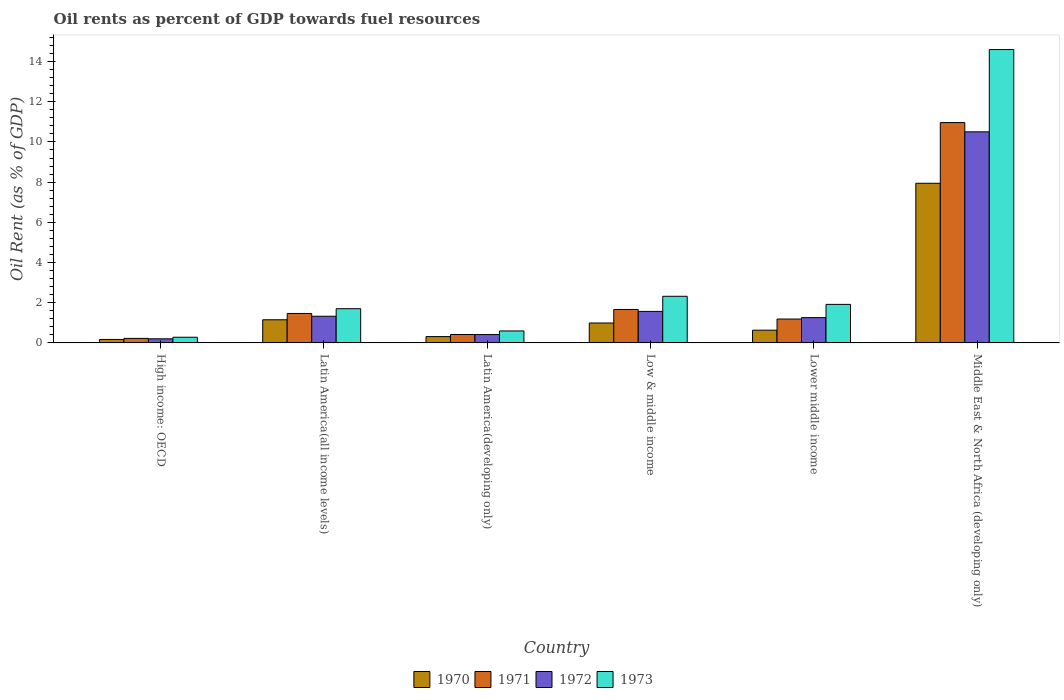How many different coloured bars are there?
Your answer should be very brief. 4. Are the number of bars per tick equal to the number of legend labels?
Give a very brief answer. Yes. In how many cases, is the number of bars for a given country not equal to the number of legend labels?
Provide a short and direct response. 0. What is the oil rent in 1973 in Latin America(developing only)?
Make the answer very short. 0.6. Across all countries, what is the maximum oil rent in 1971?
Keep it short and to the point. 10.96. Across all countries, what is the minimum oil rent in 1970?
Your answer should be compact. 0.17. In which country was the oil rent in 1972 maximum?
Ensure brevity in your answer.  Middle East & North Africa (developing only). In which country was the oil rent in 1972 minimum?
Provide a succinct answer. High income: OECD. What is the total oil rent in 1970 in the graph?
Your answer should be compact. 11.21. What is the difference between the oil rent in 1970 in Latin America(all income levels) and that in Lower middle income?
Offer a very short reply. 0.52. What is the difference between the oil rent in 1972 in Middle East & North Africa (developing only) and the oil rent in 1973 in Lower middle income?
Give a very brief answer. 8.58. What is the average oil rent in 1973 per country?
Provide a short and direct response. 3.57. What is the difference between the oil rent of/in 1972 and oil rent of/in 1971 in High income: OECD?
Give a very brief answer. -0.02. What is the ratio of the oil rent in 1973 in Latin America(all income levels) to that in Middle East & North Africa (developing only)?
Your answer should be compact. 0.12. Is the oil rent in 1970 in High income: OECD less than that in Low & middle income?
Offer a terse response. Yes. What is the difference between the highest and the second highest oil rent in 1971?
Provide a succinct answer. -9.3. What is the difference between the highest and the lowest oil rent in 1970?
Your answer should be compact. 7.77. In how many countries, is the oil rent in 1972 greater than the average oil rent in 1972 taken over all countries?
Provide a succinct answer. 1. What does the 2nd bar from the right in Low & middle income represents?
Give a very brief answer. 1972. How many bars are there?
Ensure brevity in your answer.  24. Are all the bars in the graph horizontal?
Your response must be concise. No. What is the difference between two consecutive major ticks on the Y-axis?
Your answer should be compact. 2. Does the graph contain any zero values?
Keep it short and to the point. No. How many legend labels are there?
Make the answer very short. 4. How are the legend labels stacked?
Your answer should be compact. Horizontal. What is the title of the graph?
Your response must be concise. Oil rents as percent of GDP towards fuel resources. What is the label or title of the Y-axis?
Ensure brevity in your answer.  Oil Rent (as % of GDP). What is the Oil Rent (as % of GDP) of 1970 in High income: OECD?
Keep it short and to the point. 0.17. What is the Oil Rent (as % of GDP) of 1971 in High income: OECD?
Your answer should be very brief. 0.23. What is the Oil Rent (as % of GDP) in 1972 in High income: OECD?
Your answer should be compact. 0.21. What is the Oil Rent (as % of GDP) of 1973 in High income: OECD?
Your answer should be compact. 0.28. What is the Oil Rent (as % of GDP) of 1970 in Latin America(all income levels)?
Make the answer very short. 1.15. What is the Oil Rent (as % of GDP) in 1971 in Latin America(all income levels)?
Give a very brief answer. 1.47. What is the Oil Rent (as % of GDP) in 1972 in Latin America(all income levels)?
Offer a very short reply. 1.33. What is the Oil Rent (as % of GDP) of 1973 in Latin America(all income levels)?
Give a very brief answer. 1.7. What is the Oil Rent (as % of GDP) in 1970 in Latin America(developing only)?
Offer a very short reply. 0.32. What is the Oil Rent (as % of GDP) of 1971 in Latin America(developing only)?
Your response must be concise. 0.42. What is the Oil Rent (as % of GDP) of 1972 in Latin America(developing only)?
Ensure brevity in your answer.  0.42. What is the Oil Rent (as % of GDP) in 1973 in Latin America(developing only)?
Your response must be concise. 0.6. What is the Oil Rent (as % of GDP) of 1970 in Low & middle income?
Provide a short and direct response. 0.99. What is the Oil Rent (as % of GDP) in 1971 in Low & middle income?
Your answer should be very brief. 1.67. What is the Oil Rent (as % of GDP) of 1972 in Low & middle income?
Ensure brevity in your answer.  1.57. What is the Oil Rent (as % of GDP) in 1973 in Low & middle income?
Keep it short and to the point. 2.32. What is the Oil Rent (as % of GDP) of 1970 in Lower middle income?
Ensure brevity in your answer.  0.63. What is the Oil Rent (as % of GDP) of 1971 in Lower middle income?
Give a very brief answer. 1.19. What is the Oil Rent (as % of GDP) in 1972 in Lower middle income?
Your answer should be compact. 1.26. What is the Oil Rent (as % of GDP) in 1973 in Lower middle income?
Make the answer very short. 1.92. What is the Oil Rent (as % of GDP) of 1970 in Middle East & North Africa (developing only)?
Ensure brevity in your answer.  7.94. What is the Oil Rent (as % of GDP) in 1971 in Middle East & North Africa (developing only)?
Ensure brevity in your answer.  10.96. What is the Oil Rent (as % of GDP) of 1972 in Middle East & North Africa (developing only)?
Offer a very short reply. 10.5. What is the Oil Rent (as % of GDP) of 1973 in Middle East & North Africa (developing only)?
Your answer should be compact. 14.6. Across all countries, what is the maximum Oil Rent (as % of GDP) of 1970?
Your answer should be compact. 7.94. Across all countries, what is the maximum Oil Rent (as % of GDP) in 1971?
Make the answer very short. 10.96. Across all countries, what is the maximum Oil Rent (as % of GDP) in 1972?
Provide a succinct answer. 10.5. Across all countries, what is the maximum Oil Rent (as % of GDP) in 1973?
Provide a succinct answer. 14.6. Across all countries, what is the minimum Oil Rent (as % of GDP) of 1970?
Give a very brief answer. 0.17. Across all countries, what is the minimum Oil Rent (as % of GDP) of 1971?
Keep it short and to the point. 0.23. Across all countries, what is the minimum Oil Rent (as % of GDP) in 1972?
Provide a short and direct response. 0.21. Across all countries, what is the minimum Oil Rent (as % of GDP) of 1973?
Keep it short and to the point. 0.28. What is the total Oil Rent (as % of GDP) in 1970 in the graph?
Make the answer very short. 11.21. What is the total Oil Rent (as % of GDP) in 1971 in the graph?
Your answer should be compact. 15.93. What is the total Oil Rent (as % of GDP) in 1972 in the graph?
Offer a very short reply. 15.28. What is the total Oil Rent (as % of GDP) in 1973 in the graph?
Your response must be concise. 21.42. What is the difference between the Oil Rent (as % of GDP) in 1970 in High income: OECD and that in Latin America(all income levels)?
Ensure brevity in your answer.  -0.98. What is the difference between the Oil Rent (as % of GDP) of 1971 in High income: OECD and that in Latin America(all income levels)?
Ensure brevity in your answer.  -1.24. What is the difference between the Oil Rent (as % of GDP) of 1972 in High income: OECD and that in Latin America(all income levels)?
Offer a terse response. -1.12. What is the difference between the Oil Rent (as % of GDP) of 1973 in High income: OECD and that in Latin America(all income levels)?
Offer a very short reply. -1.42. What is the difference between the Oil Rent (as % of GDP) in 1970 in High income: OECD and that in Latin America(developing only)?
Ensure brevity in your answer.  -0.14. What is the difference between the Oil Rent (as % of GDP) of 1971 in High income: OECD and that in Latin America(developing only)?
Give a very brief answer. -0.19. What is the difference between the Oil Rent (as % of GDP) of 1972 in High income: OECD and that in Latin America(developing only)?
Provide a short and direct response. -0.21. What is the difference between the Oil Rent (as % of GDP) of 1973 in High income: OECD and that in Latin America(developing only)?
Your answer should be compact. -0.31. What is the difference between the Oil Rent (as % of GDP) of 1970 in High income: OECD and that in Low & middle income?
Your answer should be compact. -0.82. What is the difference between the Oil Rent (as % of GDP) in 1971 in High income: OECD and that in Low & middle income?
Keep it short and to the point. -1.44. What is the difference between the Oil Rent (as % of GDP) of 1972 in High income: OECD and that in Low & middle income?
Provide a succinct answer. -1.36. What is the difference between the Oil Rent (as % of GDP) of 1973 in High income: OECD and that in Low & middle income?
Make the answer very short. -2.04. What is the difference between the Oil Rent (as % of GDP) in 1970 in High income: OECD and that in Lower middle income?
Offer a very short reply. -0.46. What is the difference between the Oil Rent (as % of GDP) in 1971 in High income: OECD and that in Lower middle income?
Keep it short and to the point. -0.96. What is the difference between the Oil Rent (as % of GDP) in 1972 in High income: OECD and that in Lower middle income?
Provide a short and direct response. -1.05. What is the difference between the Oil Rent (as % of GDP) in 1973 in High income: OECD and that in Lower middle income?
Your response must be concise. -1.64. What is the difference between the Oil Rent (as % of GDP) in 1970 in High income: OECD and that in Middle East & North Africa (developing only)?
Keep it short and to the point. -7.77. What is the difference between the Oil Rent (as % of GDP) in 1971 in High income: OECD and that in Middle East & North Africa (developing only)?
Offer a very short reply. -10.74. What is the difference between the Oil Rent (as % of GDP) of 1972 in High income: OECD and that in Middle East & North Africa (developing only)?
Keep it short and to the point. -10.3. What is the difference between the Oil Rent (as % of GDP) in 1973 in High income: OECD and that in Middle East & North Africa (developing only)?
Provide a short and direct response. -14.31. What is the difference between the Oil Rent (as % of GDP) of 1970 in Latin America(all income levels) and that in Latin America(developing only)?
Provide a succinct answer. 0.84. What is the difference between the Oil Rent (as % of GDP) of 1971 in Latin America(all income levels) and that in Latin America(developing only)?
Your answer should be compact. 1.05. What is the difference between the Oil Rent (as % of GDP) in 1972 in Latin America(all income levels) and that in Latin America(developing only)?
Offer a terse response. 0.91. What is the difference between the Oil Rent (as % of GDP) of 1973 in Latin America(all income levels) and that in Latin America(developing only)?
Ensure brevity in your answer.  1.11. What is the difference between the Oil Rent (as % of GDP) in 1970 in Latin America(all income levels) and that in Low & middle income?
Your response must be concise. 0.16. What is the difference between the Oil Rent (as % of GDP) of 1971 in Latin America(all income levels) and that in Low & middle income?
Ensure brevity in your answer.  -0.2. What is the difference between the Oil Rent (as % of GDP) of 1972 in Latin America(all income levels) and that in Low & middle income?
Make the answer very short. -0.24. What is the difference between the Oil Rent (as % of GDP) of 1973 in Latin America(all income levels) and that in Low & middle income?
Offer a very short reply. -0.62. What is the difference between the Oil Rent (as % of GDP) in 1970 in Latin America(all income levels) and that in Lower middle income?
Make the answer very short. 0.52. What is the difference between the Oil Rent (as % of GDP) of 1971 in Latin America(all income levels) and that in Lower middle income?
Your answer should be compact. 0.28. What is the difference between the Oil Rent (as % of GDP) of 1972 in Latin America(all income levels) and that in Lower middle income?
Give a very brief answer. 0.07. What is the difference between the Oil Rent (as % of GDP) of 1973 in Latin America(all income levels) and that in Lower middle income?
Provide a succinct answer. -0.21. What is the difference between the Oil Rent (as % of GDP) in 1970 in Latin America(all income levels) and that in Middle East & North Africa (developing only)?
Keep it short and to the point. -6.79. What is the difference between the Oil Rent (as % of GDP) of 1971 in Latin America(all income levels) and that in Middle East & North Africa (developing only)?
Offer a very short reply. -9.5. What is the difference between the Oil Rent (as % of GDP) in 1972 in Latin America(all income levels) and that in Middle East & North Africa (developing only)?
Give a very brief answer. -9.17. What is the difference between the Oil Rent (as % of GDP) of 1973 in Latin America(all income levels) and that in Middle East & North Africa (developing only)?
Make the answer very short. -12.89. What is the difference between the Oil Rent (as % of GDP) in 1970 in Latin America(developing only) and that in Low & middle income?
Your answer should be very brief. -0.68. What is the difference between the Oil Rent (as % of GDP) in 1971 in Latin America(developing only) and that in Low & middle income?
Offer a very short reply. -1.25. What is the difference between the Oil Rent (as % of GDP) in 1972 in Latin America(developing only) and that in Low & middle income?
Your answer should be compact. -1.15. What is the difference between the Oil Rent (as % of GDP) of 1973 in Latin America(developing only) and that in Low & middle income?
Offer a terse response. -1.72. What is the difference between the Oil Rent (as % of GDP) in 1970 in Latin America(developing only) and that in Lower middle income?
Offer a very short reply. -0.32. What is the difference between the Oil Rent (as % of GDP) of 1971 in Latin America(developing only) and that in Lower middle income?
Offer a terse response. -0.77. What is the difference between the Oil Rent (as % of GDP) in 1972 in Latin America(developing only) and that in Lower middle income?
Ensure brevity in your answer.  -0.84. What is the difference between the Oil Rent (as % of GDP) of 1973 in Latin America(developing only) and that in Lower middle income?
Your response must be concise. -1.32. What is the difference between the Oil Rent (as % of GDP) of 1970 in Latin America(developing only) and that in Middle East & North Africa (developing only)?
Offer a very short reply. -7.63. What is the difference between the Oil Rent (as % of GDP) in 1971 in Latin America(developing only) and that in Middle East & North Africa (developing only)?
Your response must be concise. -10.54. What is the difference between the Oil Rent (as % of GDP) of 1972 in Latin America(developing only) and that in Middle East & North Africa (developing only)?
Offer a very short reply. -10.09. What is the difference between the Oil Rent (as % of GDP) of 1973 in Latin America(developing only) and that in Middle East & North Africa (developing only)?
Make the answer very short. -14. What is the difference between the Oil Rent (as % of GDP) in 1970 in Low & middle income and that in Lower middle income?
Offer a terse response. 0.36. What is the difference between the Oil Rent (as % of GDP) of 1971 in Low & middle income and that in Lower middle income?
Keep it short and to the point. 0.48. What is the difference between the Oil Rent (as % of GDP) in 1972 in Low & middle income and that in Lower middle income?
Make the answer very short. 0.31. What is the difference between the Oil Rent (as % of GDP) of 1973 in Low & middle income and that in Lower middle income?
Offer a terse response. 0.4. What is the difference between the Oil Rent (as % of GDP) in 1970 in Low & middle income and that in Middle East & North Africa (developing only)?
Offer a terse response. -6.95. What is the difference between the Oil Rent (as % of GDP) of 1971 in Low & middle income and that in Middle East & North Africa (developing only)?
Give a very brief answer. -9.3. What is the difference between the Oil Rent (as % of GDP) in 1972 in Low & middle income and that in Middle East & North Africa (developing only)?
Offer a very short reply. -8.93. What is the difference between the Oil Rent (as % of GDP) in 1973 in Low & middle income and that in Middle East & North Africa (developing only)?
Your answer should be compact. -12.28. What is the difference between the Oil Rent (as % of GDP) in 1970 in Lower middle income and that in Middle East & North Africa (developing only)?
Provide a succinct answer. -7.31. What is the difference between the Oil Rent (as % of GDP) in 1971 in Lower middle income and that in Middle East & North Africa (developing only)?
Provide a short and direct response. -9.77. What is the difference between the Oil Rent (as % of GDP) of 1972 in Lower middle income and that in Middle East & North Africa (developing only)?
Offer a terse response. -9.24. What is the difference between the Oil Rent (as % of GDP) in 1973 in Lower middle income and that in Middle East & North Africa (developing only)?
Provide a succinct answer. -12.68. What is the difference between the Oil Rent (as % of GDP) in 1970 in High income: OECD and the Oil Rent (as % of GDP) in 1971 in Latin America(all income levels)?
Your response must be concise. -1.29. What is the difference between the Oil Rent (as % of GDP) in 1970 in High income: OECD and the Oil Rent (as % of GDP) in 1972 in Latin America(all income levels)?
Your response must be concise. -1.15. What is the difference between the Oil Rent (as % of GDP) of 1970 in High income: OECD and the Oil Rent (as % of GDP) of 1973 in Latin America(all income levels)?
Your answer should be very brief. -1.53. What is the difference between the Oil Rent (as % of GDP) of 1971 in High income: OECD and the Oil Rent (as % of GDP) of 1972 in Latin America(all income levels)?
Keep it short and to the point. -1.1. What is the difference between the Oil Rent (as % of GDP) in 1971 in High income: OECD and the Oil Rent (as % of GDP) in 1973 in Latin America(all income levels)?
Your answer should be compact. -1.48. What is the difference between the Oil Rent (as % of GDP) in 1972 in High income: OECD and the Oil Rent (as % of GDP) in 1973 in Latin America(all income levels)?
Provide a succinct answer. -1.5. What is the difference between the Oil Rent (as % of GDP) in 1970 in High income: OECD and the Oil Rent (as % of GDP) in 1971 in Latin America(developing only)?
Your answer should be compact. -0.25. What is the difference between the Oil Rent (as % of GDP) of 1970 in High income: OECD and the Oil Rent (as % of GDP) of 1972 in Latin America(developing only)?
Provide a short and direct response. -0.24. What is the difference between the Oil Rent (as % of GDP) of 1970 in High income: OECD and the Oil Rent (as % of GDP) of 1973 in Latin America(developing only)?
Ensure brevity in your answer.  -0.42. What is the difference between the Oil Rent (as % of GDP) in 1971 in High income: OECD and the Oil Rent (as % of GDP) in 1972 in Latin America(developing only)?
Your response must be concise. -0.19. What is the difference between the Oil Rent (as % of GDP) of 1971 in High income: OECD and the Oil Rent (as % of GDP) of 1973 in Latin America(developing only)?
Offer a very short reply. -0.37. What is the difference between the Oil Rent (as % of GDP) of 1972 in High income: OECD and the Oil Rent (as % of GDP) of 1973 in Latin America(developing only)?
Your answer should be compact. -0.39. What is the difference between the Oil Rent (as % of GDP) in 1970 in High income: OECD and the Oil Rent (as % of GDP) in 1971 in Low & middle income?
Your answer should be compact. -1.49. What is the difference between the Oil Rent (as % of GDP) in 1970 in High income: OECD and the Oil Rent (as % of GDP) in 1972 in Low & middle income?
Make the answer very short. -1.4. What is the difference between the Oil Rent (as % of GDP) in 1970 in High income: OECD and the Oil Rent (as % of GDP) in 1973 in Low & middle income?
Provide a succinct answer. -2.15. What is the difference between the Oil Rent (as % of GDP) in 1971 in High income: OECD and the Oil Rent (as % of GDP) in 1972 in Low & middle income?
Your answer should be compact. -1.34. What is the difference between the Oil Rent (as % of GDP) of 1971 in High income: OECD and the Oil Rent (as % of GDP) of 1973 in Low & middle income?
Your answer should be compact. -2.1. What is the difference between the Oil Rent (as % of GDP) of 1972 in High income: OECD and the Oil Rent (as % of GDP) of 1973 in Low & middle income?
Make the answer very short. -2.12. What is the difference between the Oil Rent (as % of GDP) of 1970 in High income: OECD and the Oil Rent (as % of GDP) of 1971 in Lower middle income?
Give a very brief answer. -1.02. What is the difference between the Oil Rent (as % of GDP) of 1970 in High income: OECD and the Oil Rent (as % of GDP) of 1972 in Lower middle income?
Give a very brief answer. -1.09. What is the difference between the Oil Rent (as % of GDP) of 1970 in High income: OECD and the Oil Rent (as % of GDP) of 1973 in Lower middle income?
Give a very brief answer. -1.74. What is the difference between the Oil Rent (as % of GDP) of 1971 in High income: OECD and the Oil Rent (as % of GDP) of 1972 in Lower middle income?
Your answer should be compact. -1.03. What is the difference between the Oil Rent (as % of GDP) of 1971 in High income: OECD and the Oil Rent (as % of GDP) of 1973 in Lower middle income?
Your response must be concise. -1.69. What is the difference between the Oil Rent (as % of GDP) of 1972 in High income: OECD and the Oil Rent (as % of GDP) of 1973 in Lower middle income?
Your response must be concise. -1.71. What is the difference between the Oil Rent (as % of GDP) of 1970 in High income: OECD and the Oil Rent (as % of GDP) of 1971 in Middle East & North Africa (developing only)?
Ensure brevity in your answer.  -10.79. What is the difference between the Oil Rent (as % of GDP) of 1970 in High income: OECD and the Oil Rent (as % of GDP) of 1972 in Middle East & North Africa (developing only)?
Offer a very short reply. -10.33. What is the difference between the Oil Rent (as % of GDP) in 1970 in High income: OECD and the Oil Rent (as % of GDP) in 1973 in Middle East & North Africa (developing only)?
Your answer should be compact. -14.42. What is the difference between the Oil Rent (as % of GDP) of 1971 in High income: OECD and the Oil Rent (as % of GDP) of 1972 in Middle East & North Africa (developing only)?
Offer a very short reply. -10.28. What is the difference between the Oil Rent (as % of GDP) of 1971 in High income: OECD and the Oil Rent (as % of GDP) of 1973 in Middle East & North Africa (developing only)?
Provide a succinct answer. -14.37. What is the difference between the Oil Rent (as % of GDP) of 1972 in High income: OECD and the Oil Rent (as % of GDP) of 1973 in Middle East & North Africa (developing only)?
Your answer should be compact. -14.39. What is the difference between the Oil Rent (as % of GDP) in 1970 in Latin America(all income levels) and the Oil Rent (as % of GDP) in 1971 in Latin America(developing only)?
Your response must be concise. 0.73. What is the difference between the Oil Rent (as % of GDP) of 1970 in Latin America(all income levels) and the Oil Rent (as % of GDP) of 1972 in Latin America(developing only)?
Offer a very short reply. 0.74. What is the difference between the Oil Rent (as % of GDP) in 1970 in Latin America(all income levels) and the Oil Rent (as % of GDP) in 1973 in Latin America(developing only)?
Make the answer very short. 0.56. What is the difference between the Oil Rent (as % of GDP) in 1971 in Latin America(all income levels) and the Oil Rent (as % of GDP) in 1972 in Latin America(developing only)?
Keep it short and to the point. 1.05. What is the difference between the Oil Rent (as % of GDP) of 1971 in Latin America(all income levels) and the Oil Rent (as % of GDP) of 1973 in Latin America(developing only)?
Your response must be concise. 0.87. What is the difference between the Oil Rent (as % of GDP) in 1972 in Latin America(all income levels) and the Oil Rent (as % of GDP) in 1973 in Latin America(developing only)?
Provide a short and direct response. 0.73. What is the difference between the Oil Rent (as % of GDP) of 1970 in Latin America(all income levels) and the Oil Rent (as % of GDP) of 1971 in Low & middle income?
Provide a succinct answer. -0.51. What is the difference between the Oil Rent (as % of GDP) in 1970 in Latin America(all income levels) and the Oil Rent (as % of GDP) in 1972 in Low & middle income?
Your response must be concise. -0.42. What is the difference between the Oil Rent (as % of GDP) of 1970 in Latin America(all income levels) and the Oil Rent (as % of GDP) of 1973 in Low & middle income?
Give a very brief answer. -1.17. What is the difference between the Oil Rent (as % of GDP) in 1971 in Latin America(all income levels) and the Oil Rent (as % of GDP) in 1972 in Low & middle income?
Ensure brevity in your answer.  -0.1. What is the difference between the Oil Rent (as % of GDP) in 1971 in Latin America(all income levels) and the Oil Rent (as % of GDP) in 1973 in Low & middle income?
Your response must be concise. -0.85. What is the difference between the Oil Rent (as % of GDP) in 1972 in Latin America(all income levels) and the Oil Rent (as % of GDP) in 1973 in Low & middle income?
Give a very brief answer. -0.99. What is the difference between the Oil Rent (as % of GDP) of 1970 in Latin America(all income levels) and the Oil Rent (as % of GDP) of 1971 in Lower middle income?
Give a very brief answer. -0.04. What is the difference between the Oil Rent (as % of GDP) in 1970 in Latin America(all income levels) and the Oil Rent (as % of GDP) in 1972 in Lower middle income?
Offer a terse response. -0.11. What is the difference between the Oil Rent (as % of GDP) of 1970 in Latin America(all income levels) and the Oil Rent (as % of GDP) of 1973 in Lower middle income?
Keep it short and to the point. -0.77. What is the difference between the Oil Rent (as % of GDP) of 1971 in Latin America(all income levels) and the Oil Rent (as % of GDP) of 1972 in Lower middle income?
Ensure brevity in your answer.  0.21. What is the difference between the Oil Rent (as % of GDP) in 1971 in Latin America(all income levels) and the Oil Rent (as % of GDP) in 1973 in Lower middle income?
Offer a terse response. -0.45. What is the difference between the Oil Rent (as % of GDP) in 1972 in Latin America(all income levels) and the Oil Rent (as % of GDP) in 1973 in Lower middle income?
Give a very brief answer. -0.59. What is the difference between the Oil Rent (as % of GDP) in 1970 in Latin America(all income levels) and the Oil Rent (as % of GDP) in 1971 in Middle East & North Africa (developing only)?
Provide a succinct answer. -9.81. What is the difference between the Oil Rent (as % of GDP) of 1970 in Latin America(all income levels) and the Oil Rent (as % of GDP) of 1972 in Middle East & North Africa (developing only)?
Ensure brevity in your answer.  -9.35. What is the difference between the Oil Rent (as % of GDP) in 1970 in Latin America(all income levels) and the Oil Rent (as % of GDP) in 1973 in Middle East & North Africa (developing only)?
Make the answer very short. -13.44. What is the difference between the Oil Rent (as % of GDP) of 1971 in Latin America(all income levels) and the Oil Rent (as % of GDP) of 1972 in Middle East & North Africa (developing only)?
Your answer should be very brief. -9.04. What is the difference between the Oil Rent (as % of GDP) of 1971 in Latin America(all income levels) and the Oil Rent (as % of GDP) of 1973 in Middle East & North Africa (developing only)?
Your response must be concise. -13.13. What is the difference between the Oil Rent (as % of GDP) of 1972 in Latin America(all income levels) and the Oil Rent (as % of GDP) of 1973 in Middle East & North Africa (developing only)?
Provide a succinct answer. -13.27. What is the difference between the Oil Rent (as % of GDP) of 1970 in Latin America(developing only) and the Oil Rent (as % of GDP) of 1971 in Low & middle income?
Offer a terse response. -1.35. What is the difference between the Oil Rent (as % of GDP) in 1970 in Latin America(developing only) and the Oil Rent (as % of GDP) in 1972 in Low & middle income?
Keep it short and to the point. -1.25. What is the difference between the Oil Rent (as % of GDP) in 1970 in Latin America(developing only) and the Oil Rent (as % of GDP) in 1973 in Low & middle income?
Your answer should be very brief. -2.01. What is the difference between the Oil Rent (as % of GDP) of 1971 in Latin America(developing only) and the Oil Rent (as % of GDP) of 1972 in Low & middle income?
Make the answer very short. -1.15. What is the difference between the Oil Rent (as % of GDP) of 1971 in Latin America(developing only) and the Oil Rent (as % of GDP) of 1973 in Low & middle income?
Provide a succinct answer. -1.9. What is the difference between the Oil Rent (as % of GDP) in 1972 in Latin America(developing only) and the Oil Rent (as % of GDP) in 1973 in Low & middle income?
Provide a succinct answer. -1.9. What is the difference between the Oil Rent (as % of GDP) of 1970 in Latin America(developing only) and the Oil Rent (as % of GDP) of 1971 in Lower middle income?
Your response must be concise. -0.87. What is the difference between the Oil Rent (as % of GDP) of 1970 in Latin America(developing only) and the Oil Rent (as % of GDP) of 1972 in Lower middle income?
Your answer should be compact. -0.94. What is the difference between the Oil Rent (as % of GDP) in 1970 in Latin America(developing only) and the Oil Rent (as % of GDP) in 1973 in Lower middle income?
Offer a terse response. -1.6. What is the difference between the Oil Rent (as % of GDP) of 1971 in Latin America(developing only) and the Oil Rent (as % of GDP) of 1972 in Lower middle income?
Offer a very short reply. -0.84. What is the difference between the Oil Rent (as % of GDP) in 1971 in Latin America(developing only) and the Oil Rent (as % of GDP) in 1973 in Lower middle income?
Provide a short and direct response. -1.5. What is the difference between the Oil Rent (as % of GDP) of 1972 in Latin America(developing only) and the Oil Rent (as % of GDP) of 1973 in Lower middle income?
Keep it short and to the point. -1.5. What is the difference between the Oil Rent (as % of GDP) of 1970 in Latin America(developing only) and the Oil Rent (as % of GDP) of 1971 in Middle East & North Africa (developing only)?
Give a very brief answer. -10.65. What is the difference between the Oil Rent (as % of GDP) of 1970 in Latin America(developing only) and the Oil Rent (as % of GDP) of 1972 in Middle East & North Africa (developing only)?
Provide a succinct answer. -10.19. What is the difference between the Oil Rent (as % of GDP) in 1970 in Latin America(developing only) and the Oil Rent (as % of GDP) in 1973 in Middle East & North Africa (developing only)?
Provide a short and direct response. -14.28. What is the difference between the Oil Rent (as % of GDP) of 1971 in Latin America(developing only) and the Oil Rent (as % of GDP) of 1972 in Middle East & North Africa (developing only)?
Your answer should be very brief. -10.08. What is the difference between the Oil Rent (as % of GDP) in 1971 in Latin America(developing only) and the Oil Rent (as % of GDP) in 1973 in Middle East & North Africa (developing only)?
Provide a succinct answer. -14.18. What is the difference between the Oil Rent (as % of GDP) in 1972 in Latin America(developing only) and the Oil Rent (as % of GDP) in 1973 in Middle East & North Africa (developing only)?
Your answer should be compact. -14.18. What is the difference between the Oil Rent (as % of GDP) in 1970 in Low & middle income and the Oil Rent (as % of GDP) in 1971 in Lower middle income?
Offer a very short reply. -0.2. What is the difference between the Oil Rent (as % of GDP) of 1970 in Low & middle income and the Oil Rent (as % of GDP) of 1972 in Lower middle income?
Your response must be concise. -0.27. What is the difference between the Oil Rent (as % of GDP) of 1970 in Low & middle income and the Oil Rent (as % of GDP) of 1973 in Lower middle income?
Keep it short and to the point. -0.93. What is the difference between the Oil Rent (as % of GDP) in 1971 in Low & middle income and the Oil Rent (as % of GDP) in 1972 in Lower middle income?
Your response must be concise. 0.41. What is the difference between the Oil Rent (as % of GDP) in 1971 in Low & middle income and the Oil Rent (as % of GDP) in 1973 in Lower middle income?
Provide a succinct answer. -0.25. What is the difference between the Oil Rent (as % of GDP) in 1972 in Low & middle income and the Oil Rent (as % of GDP) in 1973 in Lower middle income?
Provide a short and direct response. -0.35. What is the difference between the Oil Rent (as % of GDP) in 1970 in Low & middle income and the Oil Rent (as % of GDP) in 1971 in Middle East & North Africa (developing only)?
Ensure brevity in your answer.  -9.97. What is the difference between the Oil Rent (as % of GDP) of 1970 in Low & middle income and the Oil Rent (as % of GDP) of 1972 in Middle East & North Africa (developing only)?
Your answer should be compact. -9.51. What is the difference between the Oil Rent (as % of GDP) of 1970 in Low & middle income and the Oil Rent (as % of GDP) of 1973 in Middle East & North Africa (developing only)?
Your answer should be very brief. -13.6. What is the difference between the Oil Rent (as % of GDP) in 1971 in Low & middle income and the Oil Rent (as % of GDP) in 1972 in Middle East & North Africa (developing only)?
Give a very brief answer. -8.84. What is the difference between the Oil Rent (as % of GDP) of 1971 in Low & middle income and the Oil Rent (as % of GDP) of 1973 in Middle East & North Africa (developing only)?
Give a very brief answer. -12.93. What is the difference between the Oil Rent (as % of GDP) of 1972 in Low & middle income and the Oil Rent (as % of GDP) of 1973 in Middle East & North Africa (developing only)?
Offer a very short reply. -13.03. What is the difference between the Oil Rent (as % of GDP) in 1970 in Lower middle income and the Oil Rent (as % of GDP) in 1971 in Middle East & North Africa (developing only)?
Keep it short and to the point. -10.33. What is the difference between the Oil Rent (as % of GDP) in 1970 in Lower middle income and the Oil Rent (as % of GDP) in 1972 in Middle East & North Africa (developing only)?
Provide a short and direct response. -9.87. What is the difference between the Oil Rent (as % of GDP) of 1970 in Lower middle income and the Oil Rent (as % of GDP) of 1973 in Middle East & North Africa (developing only)?
Your answer should be very brief. -13.96. What is the difference between the Oil Rent (as % of GDP) of 1971 in Lower middle income and the Oil Rent (as % of GDP) of 1972 in Middle East & North Africa (developing only)?
Your answer should be very brief. -9.31. What is the difference between the Oil Rent (as % of GDP) of 1971 in Lower middle income and the Oil Rent (as % of GDP) of 1973 in Middle East & North Africa (developing only)?
Give a very brief answer. -13.41. What is the difference between the Oil Rent (as % of GDP) of 1972 in Lower middle income and the Oil Rent (as % of GDP) of 1973 in Middle East & North Africa (developing only)?
Make the answer very short. -13.34. What is the average Oil Rent (as % of GDP) of 1970 per country?
Your answer should be compact. 1.87. What is the average Oil Rent (as % of GDP) of 1971 per country?
Make the answer very short. 2.66. What is the average Oil Rent (as % of GDP) of 1972 per country?
Your answer should be very brief. 2.55. What is the average Oil Rent (as % of GDP) of 1973 per country?
Offer a very short reply. 3.57. What is the difference between the Oil Rent (as % of GDP) of 1970 and Oil Rent (as % of GDP) of 1971 in High income: OECD?
Your response must be concise. -0.05. What is the difference between the Oil Rent (as % of GDP) in 1970 and Oil Rent (as % of GDP) in 1972 in High income: OECD?
Provide a succinct answer. -0.03. What is the difference between the Oil Rent (as % of GDP) in 1970 and Oil Rent (as % of GDP) in 1973 in High income: OECD?
Your response must be concise. -0.11. What is the difference between the Oil Rent (as % of GDP) of 1971 and Oil Rent (as % of GDP) of 1973 in High income: OECD?
Offer a terse response. -0.06. What is the difference between the Oil Rent (as % of GDP) in 1972 and Oil Rent (as % of GDP) in 1973 in High income: OECD?
Give a very brief answer. -0.08. What is the difference between the Oil Rent (as % of GDP) in 1970 and Oil Rent (as % of GDP) in 1971 in Latin America(all income levels)?
Make the answer very short. -0.31. What is the difference between the Oil Rent (as % of GDP) of 1970 and Oil Rent (as % of GDP) of 1972 in Latin America(all income levels)?
Keep it short and to the point. -0.18. What is the difference between the Oil Rent (as % of GDP) of 1970 and Oil Rent (as % of GDP) of 1973 in Latin America(all income levels)?
Make the answer very short. -0.55. What is the difference between the Oil Rent (as % of GDP) in 1971 and Oil Rent (as % of GDP) in 1972 in Latin America(all income levels)?
Make the answer very short. 0.14. What is the difference between the Oil Rent (as % of GDP) in 1971 and Oil Rent (as % of GDP) in 1973 in Latin America(all income levels)?
Your answer should be compact. -0.24. What is the difference between the Oil Rent (as % of GDP) of 1972 and Oil Rent (as % of GDP) of 1973 in Latin America(all income levels)?
Your response must be concise. -0.38. What is the difference between the Oil Rent (as % of GDP) of 1970 and Oil Rent (as % of GDP) of 1971 in Latin America(developing only)?
Provide a succinct answer. -0.1. What is the difference between the Oil Rent (as % of GDP) of 1970 and Oil Rent (as % of GDP) of 1972 in Latin America(developing only)?
Your response must be concise. -0.1. What is the difference between the Oil Rent (as % of GDP) in 1970 and Oil Rent (as % of GDP) in 1973 in Latin America(developing only)?
Offer a very short reply. -0.28. What is the difference between the Oil Rent (as % of GDP) of 1971 and Oil Rent (as % of GDP) of 1972 in Latin America(developing only)?
Your answer should be compact. 0. What is the difference between the Oil Rent (as % of GDP) in 1971 and Oil Rent (as % of GDP) in 1973 in Latin America(developing only)?
Keep it short and to the point. -0.18. What is the difference between the Oil Rent (as % of GDP) in 1972 and Oil Rent (as % of GDP) in 1973 in Latin America(developing only)?
Provide a succinct answer. -0.18. What is the difference between the Oil Rent (as % of GDP) in 1970 and Oil Rent (as % of GDP) in 1971 in Low & middle income?
Your answer should be compact. -0.67. What is the difference between the Oil Rent (as % of GDP) of 1970 and Oil Rent (as % of GDP) of 1972 in Low & middle income?
Provide a succinct answer. -0.58. What is the difference between the Oil Rent (as % of GDP) in 1970 and Oil Rent (as % of GDP) in 1973 in Low & middle income?
Your answer should be compact. -1.33. What is the difference between the Oil Rent (as % of GDP) of 1971 and Oil Rent (as % of GDP) of 1972 in Low & middle income?
Your response must be concise. 0.1. What is the difference between the Oil Rent (as % of GDP) in 1971 and Oil Rent (as % of GDP) in 1973 in Low & middle income?
Provide a succinct answer. -0.66. What is the difference between the Oil Rent (as % of GDP) of 1972 and Oil Rent (as % of GDP) of 1973 in Low & middle income?
Offer a very short reply. -0.75. What is the difference between the Oil Rent (as % of GDP) of 1970 and Oil Rent (as % of GDP) of 1971 in Lower middle income?
Your answer should be very brief. -0.56. What is the difference between the Oil Rent (as % of GDP) of 1970 and Oil Rent (as % of GDP) of 1972 in Lower middle income?
Your answer should be compact. -0.62. What is the difference between the Oil Rent (as % of GDP) of 1970 and Oil Rent (as % of GDP) of 1973 in Lower middle income?
Ensure brevity in your answer.  -1.28. What is the difference between the Oil Rent (as % of GDP) in 1971 and Oil Rent (as % of GDP) in 1972 in Lower middle income?
Offer a very short reply. -0.07. What is the difference between the Oil Rent (as % of GDP) of 1971 and Oil Rent (as % of GDP) of 1973 in Lower middle income?
Provide a succinct answer. -0.73. What is the difference between the Oil Rent (as % of GDP) in 1972 and Oil Rent (as % of GDP) in 1973 in Lower middle income?
Provide a short and direct response. -0.66. What is the difference between the Oil Rent (as % of GDP) in 1970 and Oil Rent (as % of GDP) in 1971 in Middle East & North Africa (developing only)?
Make the answer very short. -3.02. What is the difference between the Oil Rent (as % of GDP) of 1970 and Oil Rent (as % of GDP) of 1972 in Middle East & North Africa (developing only)?
Ensure brevity in your answer.  -2.56. What is the difference between the Oil Rent (as % of GDP) in 1970 and Oil Rent (as % of GDP) in 1973 in Middle East & North Africa (developing only)?
Offer a terse response. -6.65. What is the difference between the Oil Rent (as % of GDP) in 1971 and Oil Rent (as % of GDP) in 1972 in Middle East & North Africa (developing only)?
Give a very brief answer. 0.46. What is the difference between the Oil Rent (as % of GDP) of 1971 and Oil Rent (as % of GDP) of 1973 in Middle East & North Africa (developing only)?
Make the answer very short. -3.63. What is the difference between the Oil Rent (as % of GDP) in 1972 and Oil Rent (as % of GDP) in 1973 in Middle East & North Africa (developing only)?
Offer a terse response. -4.09. What is the ratio of the Oil Rent (as % of GDP) in 1970 in High income: OECD to that in Latin America(all income levels)?
Provide a succinct answer. 0.15. What is the ratio of the Oil Rent (as % of GDP) in 1971 in High income: OECD to that in Latin America(all income levels)?
Give a very brief answer. 0.15. What is the ratio of the Oil Rent (as % of GDP) of 1972 in High income: OECD to that in Latin America(all income levels)?
Keep it short and to the point. 0.15. What is the ratio of the Oil Rent (as % of GDP) of 1973 in High income: OECD to that in Latin America(all income levels)?
Offer a very short reply. 0.17. What is the ratio of the Oil Rent (as % of GDP) of 1970 in High income: OECD to that in Latin America(developing only)?
Your response must be concise. 0.55. What is the ratio of the Oil Rent (as % of GDP) in 1971 in High income: OECD to that in Latin America(developing only)?
Make the answer very short. 0.54. What is the ratio of the Oil Rent (as % of GDP) in 1972 in High income: OECD to that in Latin America(developing only)?
Ensure brevity in your answer.  0.49. What is the ratio of the Oil Rent (as % of GDP) in 1973 in High income: OECD to that in Latin America(developing only)?
Ensure brevity in your answer.  0.47. What is the ratio of the Oil Rent (as % of GDP) of 1970 in High income: OECD to that in Low & middle income?
Ensure brevity in your answer.  0.18. What is the ratio of the Oil Rent (as % of GDP) of 1971 in High income: OECD to that in Low & middle income?
Ensure brevity in your answer.  0.14. What is the ratio of the Oil Rent (as % of GDP) in 1972 in High income: OECD to that in Low & middle income?
Offer a terse response. 0.13. What is the ratio of the Oil Rent (as % of GDP) in 1973 in High income: OECD to that in Low & middle income?
Ensure brevity in your answer.  0.12. What is the ratio of the Oil Rent (as % of GDP) of 1970 in High income: OECD to that in Lower middle income?
Provide a short and direct response. 0.27. What is the ratio of the Oil Rent (as % of GDP) in 1971 in High income: OECD to that in Lower middle income?
Offer a very short reply. 0.19. What is the ratio of the Oil Rent (as % of GDP) in 1972 in High income: OECD to that in Lower middle income?
Your answer should be very brief. 0.16. What is the ratio of the Oil Rent (as % of GDP) in 1973 in High income: OECD to that in Lower middle income?
Give a very brief answer. 0.15. What is the ratio of the Oil Rent (as % of GDP) in 1970 in High income: OECD to that in Middle East & North Africa (developing only)?
Offer a terse response. 0.02. What is the ratio of the Oil Rent (as % of GDP) of 1971 in High income: OECD to that in Middle East & North Africa (developing only)?
Make the answer very short. 0.02. What is the ratio of the Oil Rent (as % of GDP) in 1972 in High income: OECD to that in Middle East & North Africa (developing only)?
Offer a terse response. 0.02. What is the ratio of the Oil Rent (as % of GDP) in 1973 in High income: OECD to that in Middle East & North Africa (developing only)?
Provide a short and direct response. 0.02. What is the ratio of the Oil Rent (as % of GDP) of 1970 in Latin America(all income levels) to that in Latin America(developing only)?
Offer a very short reply. 3.65. What is the ratio of the Oil Rent (as % of GDP) in 1971 in Latin America(all income levels) to that in Latin America(developing only)?
Ensure brevity in your answer.  3.5. What is the ratio of the Oil Rent (as % of GDP) in 1972 in Latin America(all income levels) to that in Latin America(developing only)?
Offer a terse response. 3.19. What is the ratio of the Oil Rent (as % of GDP) in 1973 in Latin America(all income levels) to that in Latin America(developing only)?
Your answer should be very brief. 2.85. What is the ratio of the Oil Rent (as % of GDP) of 1970 in Latin America(all income levels) to that in Low & middle income?
Keep it short and to the point. 1.16. What is the ratio of the Oil Rent (as % of GDP) in 1971 in Latin America(all income levels) to that in Low & middle income?
Your answer should be compact. 0.88. What is the ratio of the Oil Rent (as % of GDP) in 1972 in Latin America(all income levels) to that in Low & middle income?
Your answer should be compact. 0.85. What is the ratio of the Oil Rent (as % of GDP) of 1973 in Latin America(all income levels) to that in Low & middle income?
Ensure brevity in your answer.  0.73. What is the ratio of the Oil Rent (as % of GDP) in 1970 in Latin America(all income levels) to that in Lower middle income?
Offer a very short reply. 1.82. What is the ratio of the Oil Rent (as % of GDP) of 1971 in Latin America(all income levels) to that in Lower middle income?
Offer a very short reply. 1.23. What is the ratio of the Oil Rent (as % of GDP) of 1972 in Latin America(all income levels) to that in Lower middle income?
Ensure brevity in your answer.  1.05. What is the ratio of the Oil Rent (as % of GDP) in 1973 in Latin America(all income levels) to that in Lower middle income?
Your answer should be very brief. 0.89. What is the ratio of the Oil Rent (as % of GDP) in 1970 in Latin America(all income levels) to that in Middle East & North Africa (developing only)?
Give a very brief answer. 0.15. What is the ratio of the Oil Rent (as % of GDP) in 1971 in Latin America(all income levels) to that in Middle East & North Africa (developing only)?
Keep it short and to the point. 0.13. What is the ratio of the Oil Rent (as % of GDP) of 1972 in Latin America(all income levels) to that in Middle East & North Africa (developing only)?
Your answer should be compact. 0.13. What is the ratio of the Oil Rent (as % of GDP) in 1973 in Latin America(all income levels) to that in Middle East & North Africa (developing only)?
Make the answer very short. 0.12. What is the ratio of the Oil Rent (as % of GDP) of 1970 in Latin America(developing only) to that in Low & middle income?
Your response must be concise. 0.32. What is the ratio of the Oil Rent (as % of GDP) in 1971 in Latin America(developing only) to that in Low & middle income?
Your response must be concise. 0.25. What is the ratio of the Oil Rent (as % of GDP) in 1972 in Latin America(developing only) to that in Low & middle income?
Keep it short and to the point. 0.27. What is the ratio of the Oil Rent (as % of GDP) of 1973 in Latin America(developing only) to that in Low & middle income?
Make the answer very short. 0.26. What is the ratio of the Oil Rent (as % of GDP) in 1970 in Latin America(developing only) to that in Lower middle income?
Your answer should be very brief. 0.5. What is the ratio of the Oil Rent (as % of GDP) of 1971 in Latin America(developing only) to that in Lower middle income?
Your answer should be compact. 0.35. What is the ratio of the Oil Rent (as % of GDP) of 1972 in Latin America(developing only) to that in Lower middle income?
Ensure brevity in your answer.  0.33. What is the ratio of the Oil Rent (as % of GDP) of 1973 in Latin America(developing only) to that in Lower middle income?
Offer a very short reply. 0.31. What is the ratio of the Oil Rent (as % of GDP) of 1970 in Latin America(developing only) to that in Middle East & North Africa (developing only)?
Make the answer very short. 0.04. What is the ratio of the Oil Rent (as % of GDP) in 1971 in Latin America(developing only) to that in Middle East & North Africa (developing only)?
Give a very brief answer. 0.04. What is the ratio of the Oil Rent (as % of GDP) of 1972 in Latin America(developing only) to that in Middle East & North Africa (developing only)?
Offer a terse response. 0.04. What is the ratio of the Oil Rent (as % of GDP) in 1973 in Latin America(developing only) to that in Middle East & North Africa (developing only)?
Give a very brief answer. 0.04. What is the ratio of the Oil Rent (as % of GDP) of 1970 in Low & middle income to that in Lower middle income?
Ensure brevity in your answer.  1.56. What is the ratio of the Oil Rent (as % of GDP) of 1971 in Low & middle income to that in Lower middle income?
Your answer should be very brief. 1.4. What is the ratio of the Oil Rent (as % of GDP) in 1972 in Low & middle income to that in Lower middle income?
Your answer should be very brief. 1.25. What is the ratio of the Oil Rent (as % of GDP) of 1973 in Low & middle income to that in Lower middle income?
Your answer should be compact. 1.21. What is the ratio of the Oil Rent (as % of GDP) of 1970 in Low & middle income to that in Middle East & North Africa (developing only)?
Your answer should be compact. 0.12. What is the ratio of the Oil Rent (as % of GDP) in 1971 in Low & middle income to that in Middle East & North Africa (developing only)?
Keep it short and to the point. 0.15. What is the ratio of the Oil Rent (as % of GDP) of 1972 in Low & middle income to that in Middle East & North Africa (developing only)?
Provide a short and direct response. 0.15. What is the ratio of the Oil Rent (as % of GDP) of 1973 in Low & middle income to that in Middle East & North Africa (developing only)?
Ensure brevity in your answer.  0.16. What is the ratio of the Oil Rent (as % of GDP) of 1970 in Lower middle income to that in Middle East & North Africa (developing only)?
Offer a terse response. 0.08. What is the ratio of the Oil Rent (as % of GDP) of 1971 in Lower middle income to that in Middle East & North Africa (developing only)?
Offer a terse response. 0.11. What is the ratio of the Oil Rent (as % of GDP) of 1972 in Lower middle income to that in Middle East & North Africa (developing only)?
Give a very brief answer. 0.12. What is the ratio of the Oil Rent (as % of GDP) in 1973 in Lower middle income to that in Middle East & North Africa (developing only)?
Give a very brief answer. 0.13. What is the difference between the highest and the second highest Oil Rent (as % of GDP) of 1970?
Provide a short and direct response. 6.79. What is the difference between the highest and the second highest Oil Rent (as % of GDP) in 1971?
Your response must be concise. 9.3. What is the difference between the highest and the second highest Oil Rent (as % of GDP) of 1972?
Give a very brief answer. 8.93. What is the difference between the highest and the second highest Oil Rent (as % of GDP) in 1973?
Your response must be concise. 12.28. What is the difference between the highest and the lowest Oil Rent (as % of GDP) of 1970?
Your response must be concise. 7.77. What is the difference between the highest and the lowest Oil Rent (as % of GDP) in 1971?
Offer a terse response. 10.74. What is the difference between the highest and the lowest Oil Rent (as % of GDP) of 1972?
Keep it short and to the point. 10.3. What is the difference between the highest and the lowest Oil Rent (as % of GDP) in 1973?
Keep it short and to the point. 14.31. 